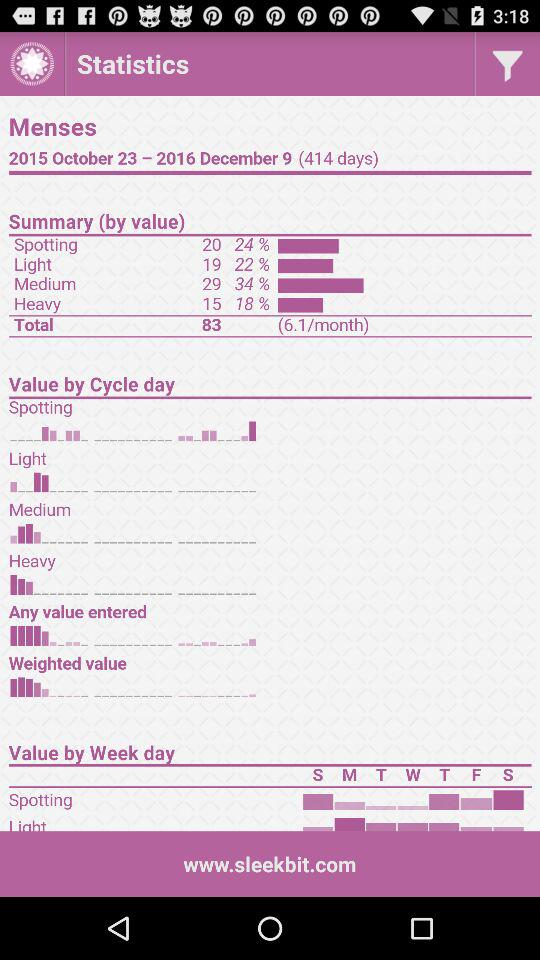How many total months are given in summary?
When the provided information is insufficient, respond with <no answer>. <no answer> 